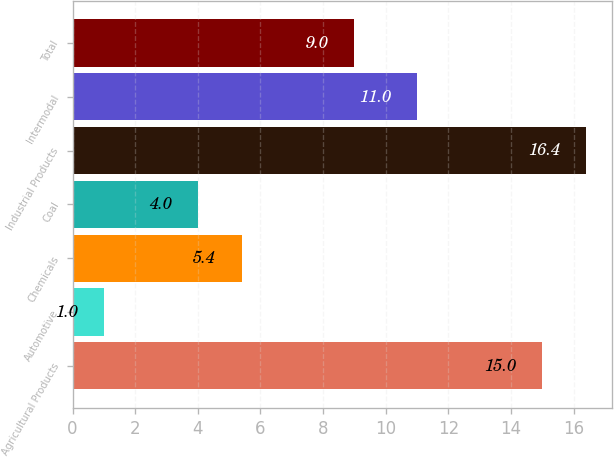Convert chart to OTSL. <chart><loc_0><loc_0><loc_500><loc_500><bar_chart><fcel>Agricultural Products<fcel>Automotive<fcel>Chemicals<fcel>Coal<fcel>Industrial Products<fcel>Intermodal<fcel>Total<nl><fcel>15<fcel>1<fcel>5.4<fcel>4<fcel>16.4<fcel>11<fcel>9<nl></chart> 